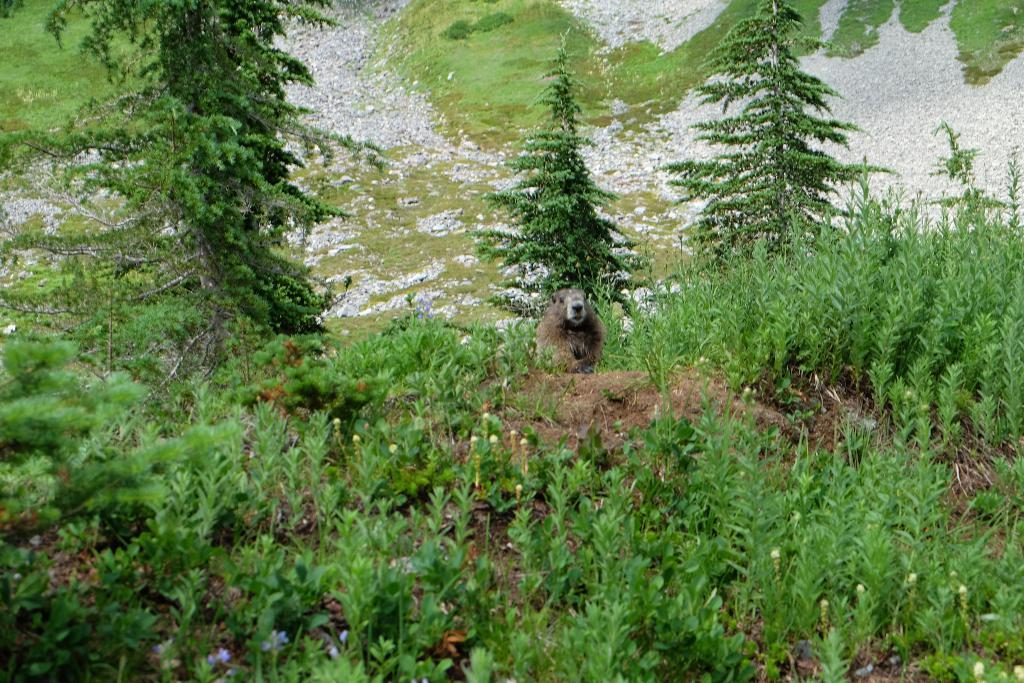What type of setting is depicted in the image? The image is an outside view. What types of vegetation can be seen in the image? There are plants and trees in the image. What is on the ground in the image? There are stones and an animal on the ground in the image. What type of prose can be heard being read by the plantation owner in the image? There is no prose or plantation owner present in the image; it is a scene of nature with plants, trees, stones, and an animal. 